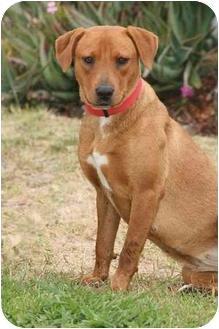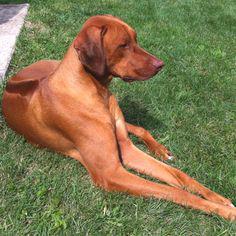The first image is the image on the left, the second image is the image on the right. Considering the images on both sides, is "The dogs in both of the images are outside." valid? Answer yes or no. Yes. The first image is the image on the left, the second image is the image on the right. Examine the images to the left and right. Is the description "One image features a dog in a collar with his head angled to the left and his tongue hanging down." accurate? Answer yes or no. No. 